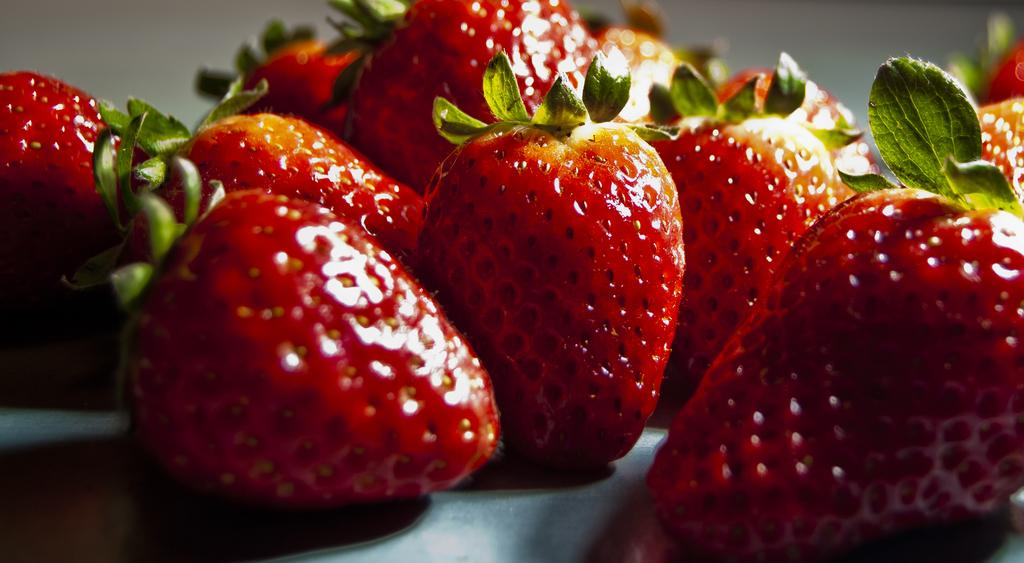What type of fruit is featured in the image? There is a group of strawberries in the image. What part of the strawberries is visible? The strawberries have leaves. Can you describe the background of the image? The background of the image is blurry. Where is the playground located in the image? There is no playground present in the image; it features a group of strawberries with leaves against a blurry background. 